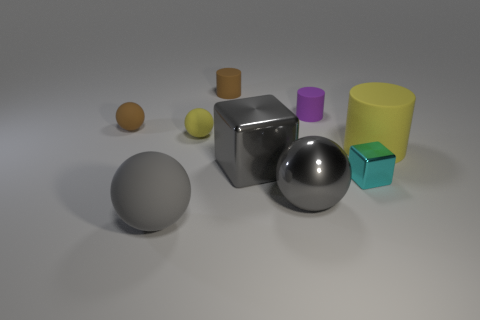There is a gray ball left of the large metallic object that is on the right side of the large metallic block; how big is it?
Your response must be concise. Large. What material is the cylinder that is the same size as the purple object?
Make the answer very short. Rubber. Is there a tiny cyan ball that has the same material as the purple cylinder?
Your answer should be very brief. No. What color is the small cylinder that is left of the big shiny object behind the gray object right of the big cube?
Ensure brevity in your answer.  Brown. Do the large matte object that is left of the yellow cylinder and the small cylinder that is left of the big shiny block have the same color?
Give a very brief answer. No. Is there anything else of the same color as the tiny shiny block?
Your answer should be very brief. No. Are there fewer cylinders left of the purple rubber thing than small yellow things?
Provide a short and direct response. No. What number of large gray metal things are there?
Provide a short and direct response. 2. Does the big gray matte thing have the same shape as the yellow thing behind the big yellow rubber cylinder?
Offer a terse response. Yes. Are there fewer gray metallic spheres behind the large yellow cylinder than small rubber cylinders in front of the shiny sphere?
Ensure brevity in your answer.  No. 